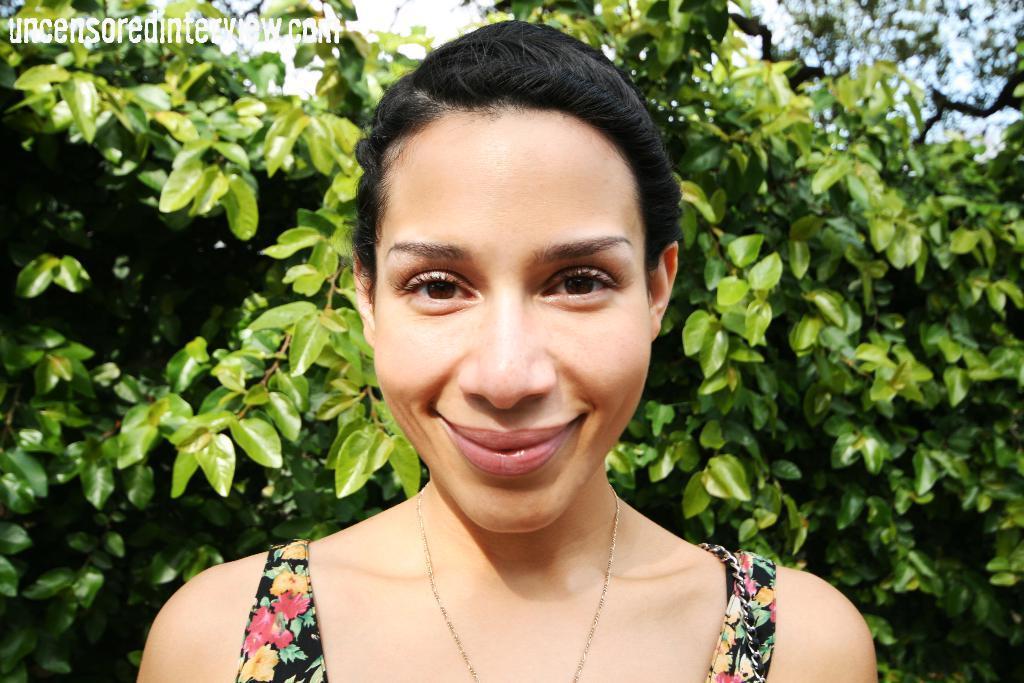Could you give a brief overview of what you see in this image? In the middle of this image, there is a woman, smiling. On the top left, there is a watermark. In the background, there are trees and there are clouds in the blue sky. 